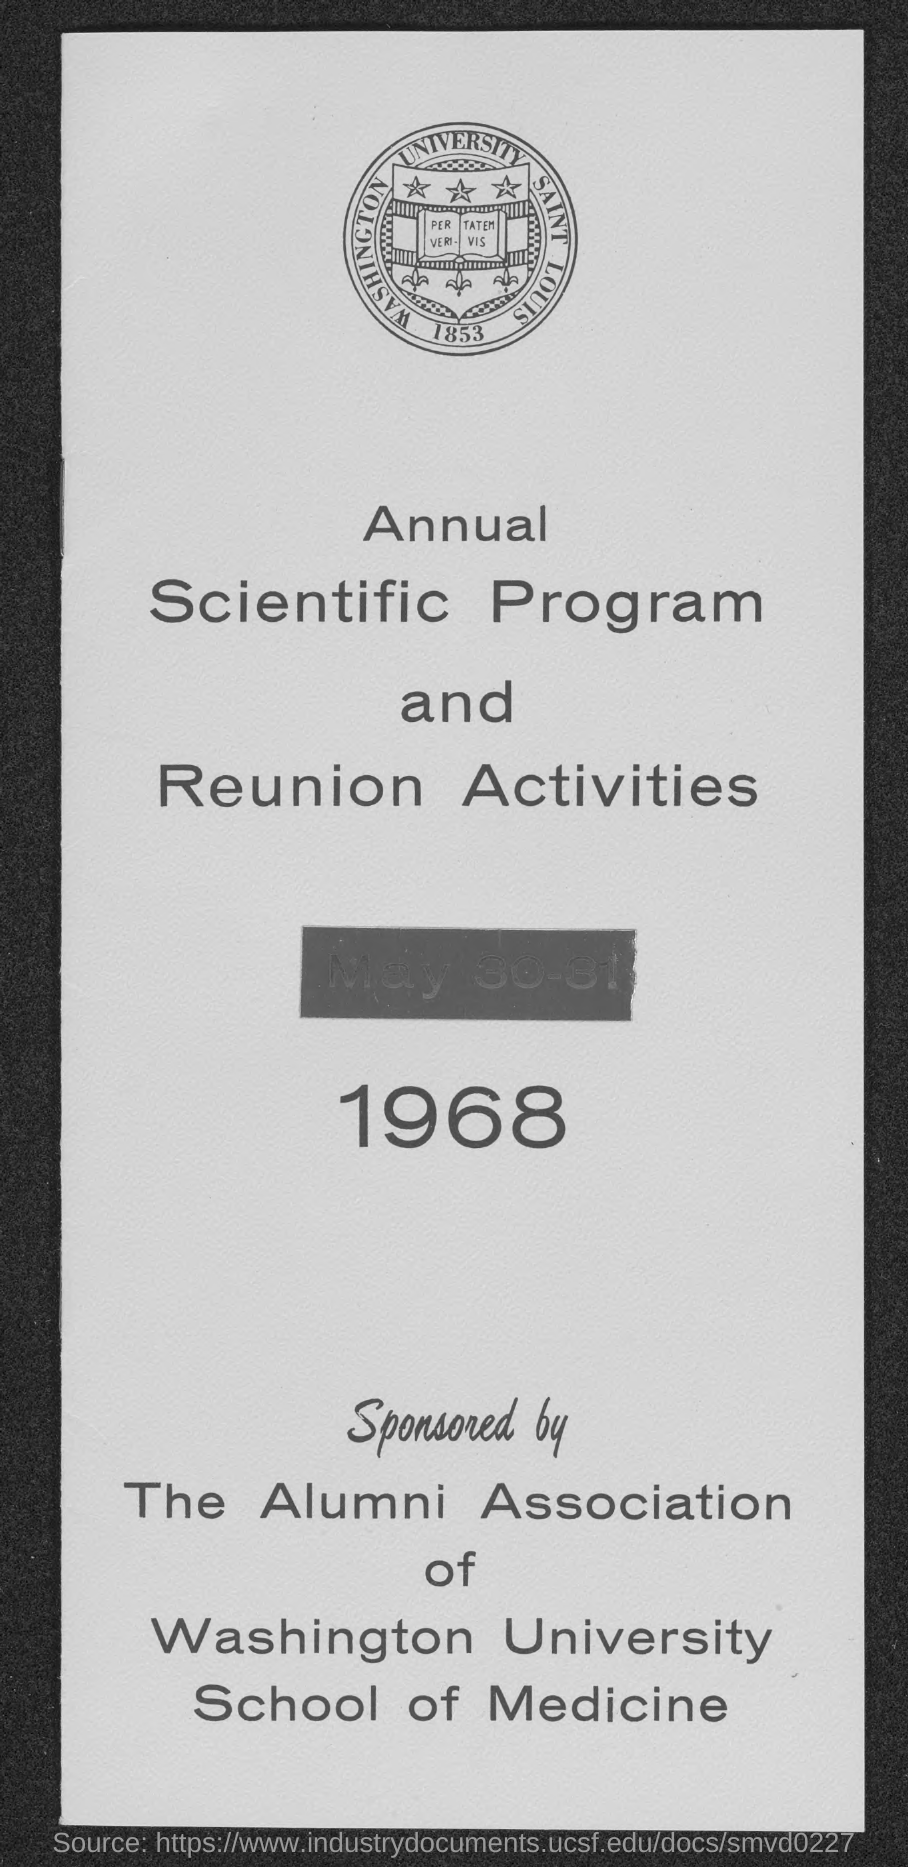Point out several critical features in this image. The date on the document is May 30-31, 1968. 